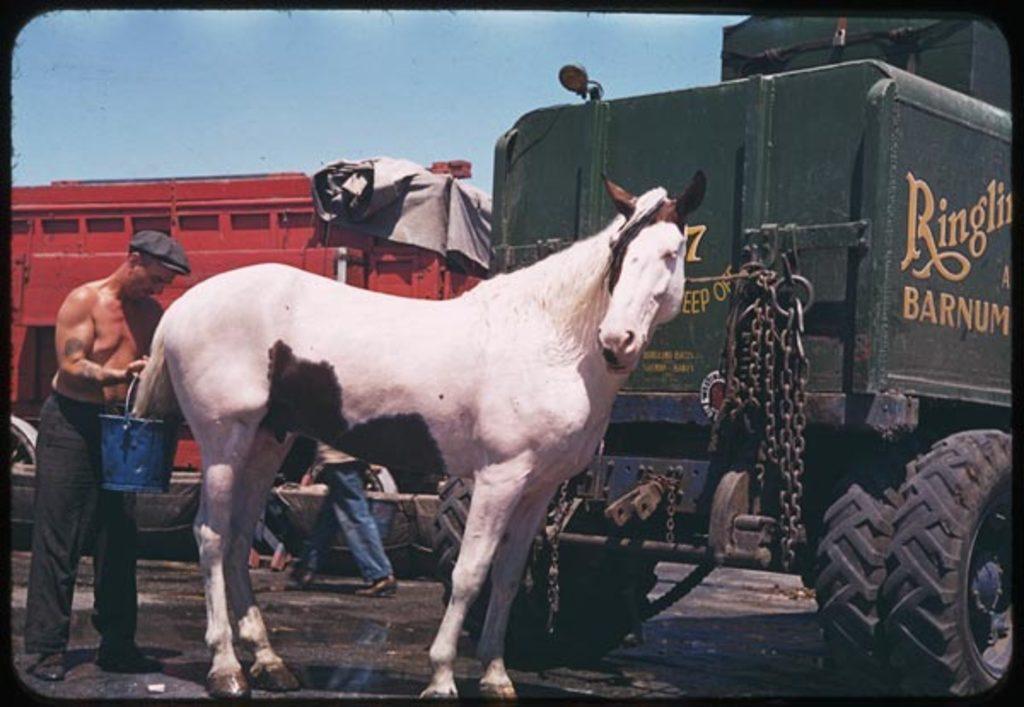Describe this image in one or two sentences. This picture shows a horse and a man holding a bucket and we see a truck 